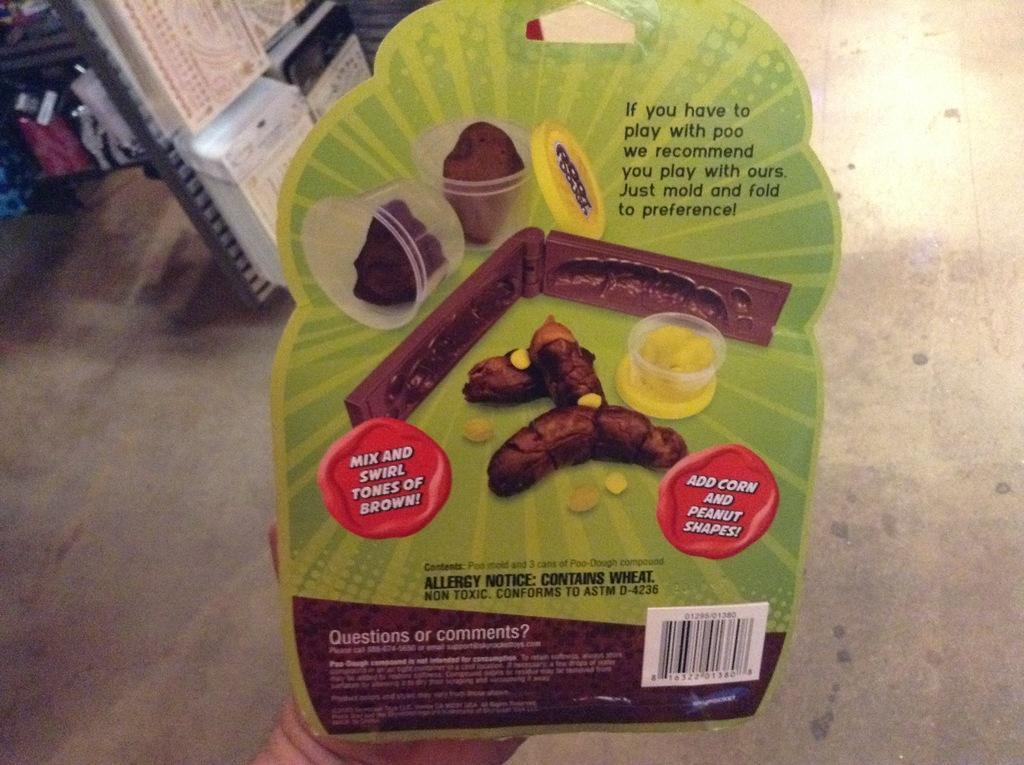How would you summarize this image in a sentence or two? In this picture we can see a person's hand, we can see something present in this hand, at the bottom there is floor. 